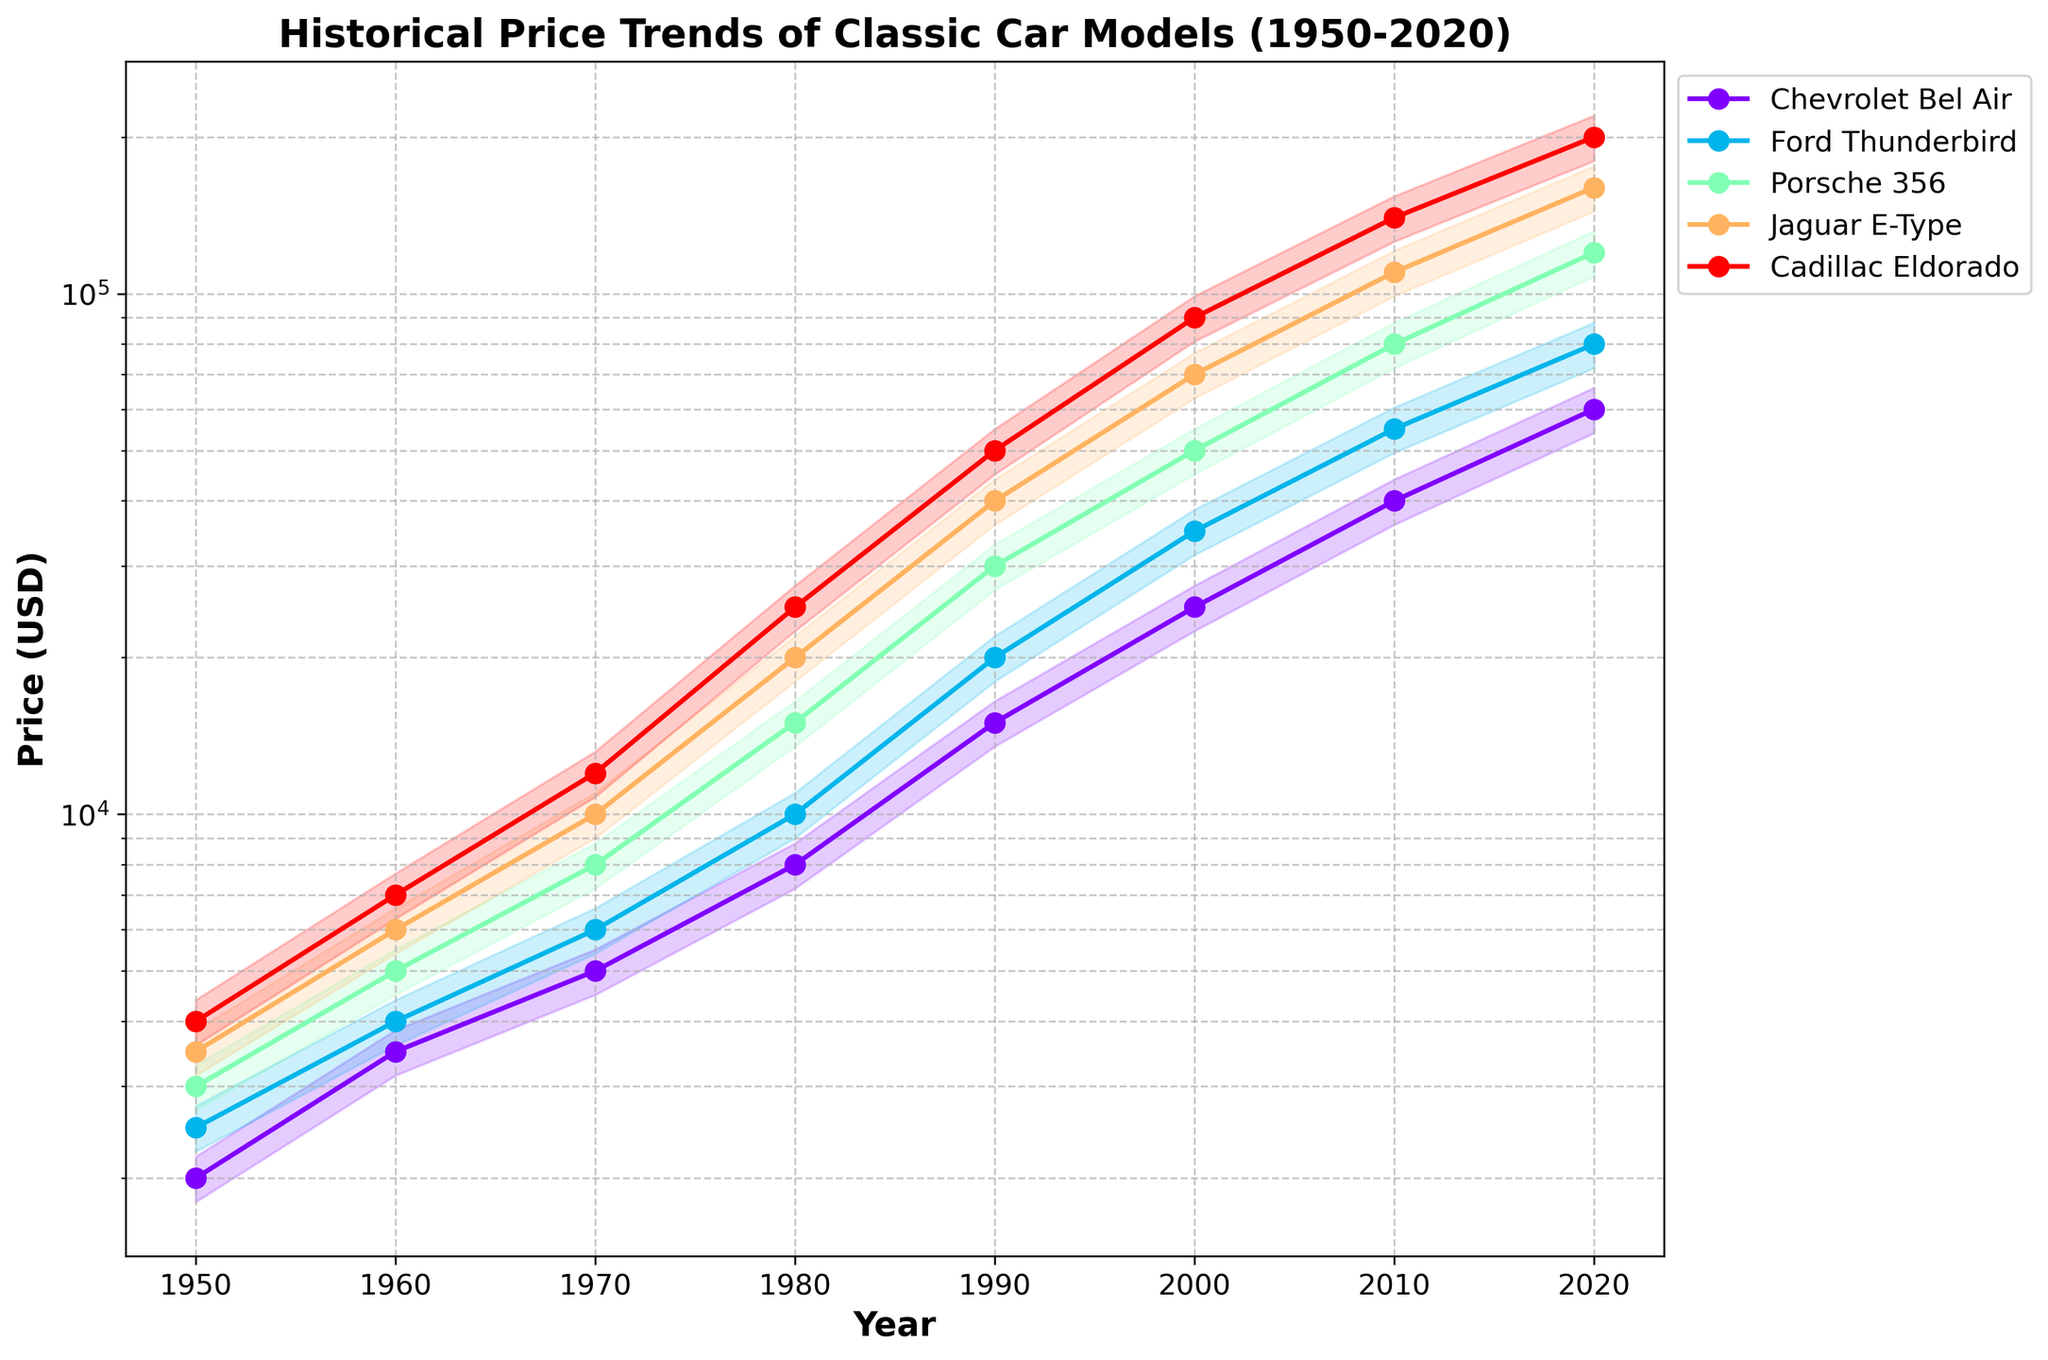What's the title of the chart? The title is typically located at the top of a chart. Here, it reads "Historical Price Trends of Classic Car Models (1950-2020)".
Answer: Historical Price Trends of Classic Car Models (1950-2020) What is the y-axis label? The y-axis label is usually placed alongside the y-axis. In this chart, it is labeled "Price (USD)".
Answer: Price (USD) What car model had the highest price in 2020? To find the answer, look at the price points for 2020. The Cadillac Eldorado clearly has the highest price at $200,000.
Answer: Cadillac Eldorado Which car had a higher price in 1990, the Porsche 356 or the Ford Thunderbird? Refer to the points corresponding to 1990 for both models. The Porsche 356 is at $30,000 and the Ford Thunderbird is at $20,000, making the Porsche more expensive.
Answer: Porsche 356 How did the Cadillac Eldorado's price change from 1950 to 2020? Identify the price in 1950 ($4,000) and in 2020 ($200,000) and calculate the difference: $200,000 - $4,000 = $196,000.
Answer: Increased by $196,000 Which car model experienced the most significant price increase between 2000 and 2020? Compare the prices in 2000 and 2020 for each car model. The Jaguar E-Type increased from $70,000 to $160,000, which is a $90,000 increase, the highest among all.
Answer: Jaguar E-Type What is the price range for the Chevrolet Bel Air in 1980 considering the confidence interval? Check the 1980 price ($8,000) and apply the 10% confidence interval: $8,800 (upper) - $7,200 (lower). Therefore, the range is $7,200 to $8,800.
Answer: $7,200 to $8,800 Which decade saw the most substantial price growth for the Porsche 356? Analyze the price growth between consecutive decades. From 1980 ($15,000) to 1990 ($30,000) for the Porsche 356, the growth is $15,000, the most substantial growth.
Answer: 1980s How many car models are tracked in the chart? Count the different car models listed in the legend or referred to in the data columns, which are five: Chevrolet Bel Air, Ford Thunderbird, Porsche 356, Jaguar E-Type, and Cadillac Eldorado.
Answer: Five What was the relative difference in price between the Chevrolet Bel Air and the Jaguar E-Type in 1960? Subtract the price of the Chevrolet Bel Air ($3,500) from the Jaguar E-Type ($6,000) and divide by the Chevrolet's price to find the relative difference: (6,000 - 3,500) / 3,500 ≈ 0.714, about 71.4%.
Answer: 71.4% 